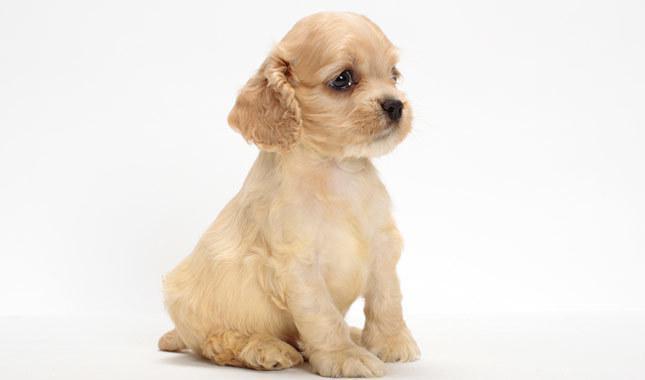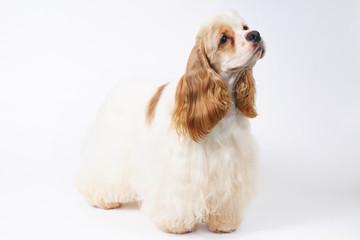The first image is the image on the left, the second image is the image on the right. Evaluate the accuracy of this statement regarding the images: "The dog in the image on the left is standing on all fours.". Is it true? Answer yes or no. No. 